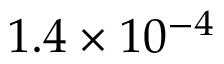Convert formula to latex. <formula><loc_0><loc_0><loc_500><loc_500>1 . 4 \times 1 0 ^ { - 4 }</formula> 